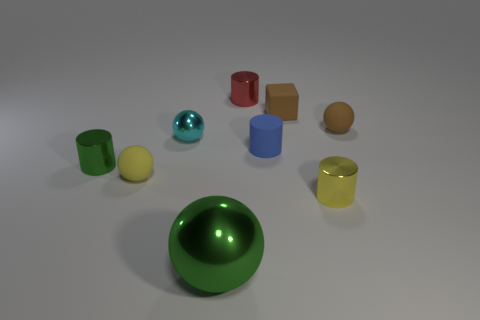Subtract 1 balls. How many balls are left? 3 Subtract all brown balls. Subtract all green blocks. How many balls are left? 3 Subtract all cylinders. How many objects are left? 5 Add 7 big balls. How many big balls exist? 8 Subtract 1 yellow spheres. How many objects are left? 8 Subtract all red things. Subtract all small shiny spheres. How many objects are left? 7 Add 6 tiny rubber cylinders. How many tiny rubber cylinders are left? 7 